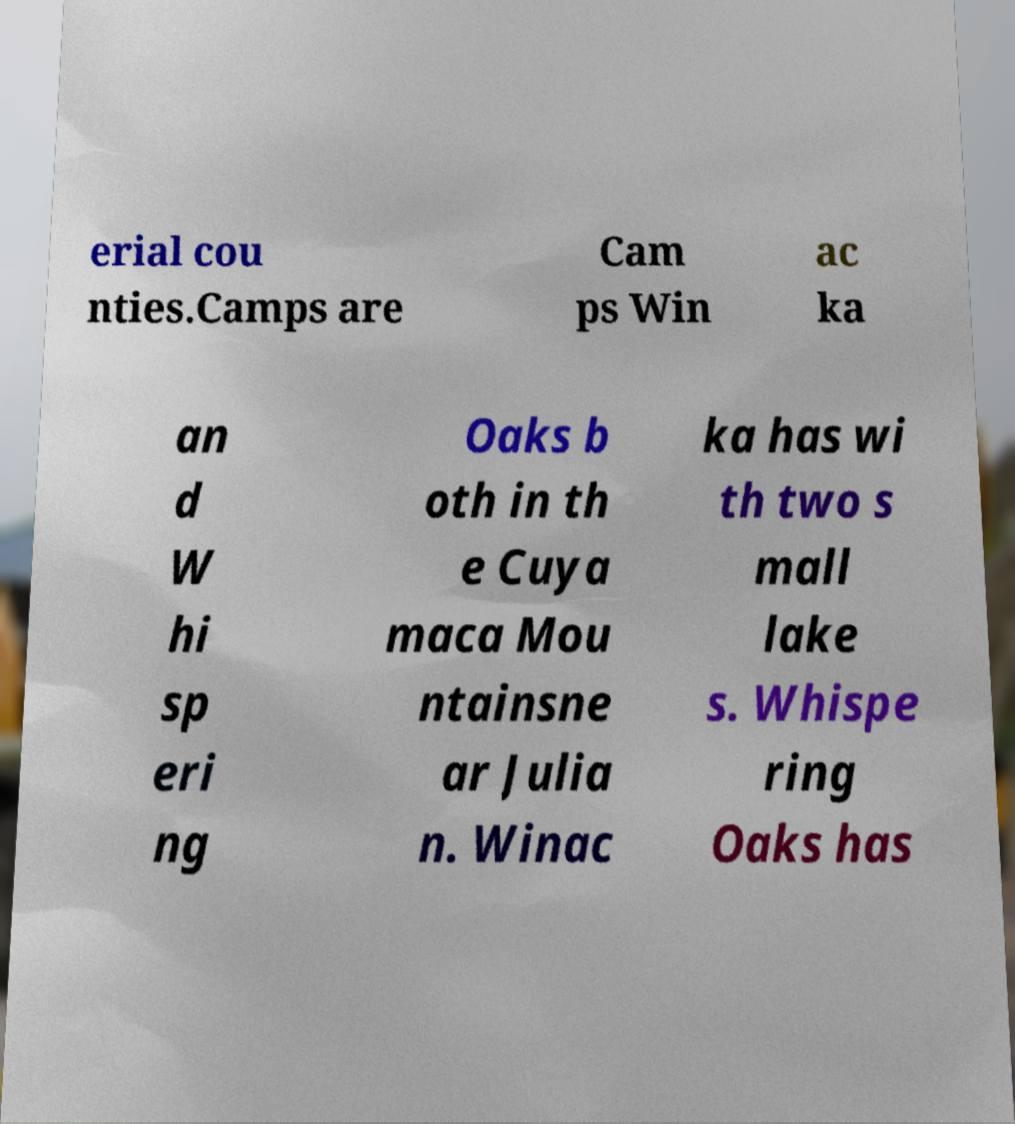Can you read and provide the text displayed in the image?This photo seems to have some interesting text. Can you extract and type it out for me? erial cou nties.Camps are Cam ps Win ac ka an d W hi sp eri ng Oaks b oth in th e Cuya maca Mou ntainsne ar Julia n. Winac ka has wi th two s mall lake s. Whispe ring Oaks has 